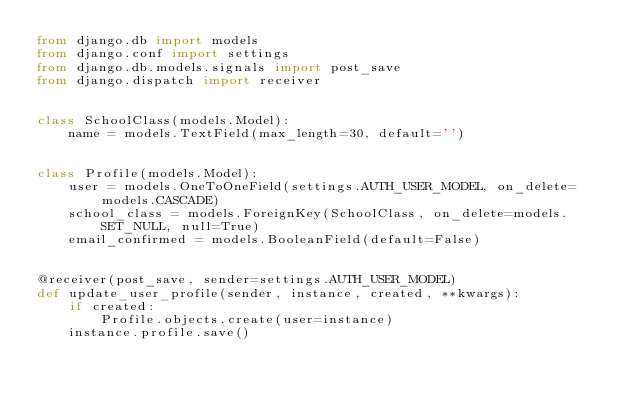<code> <loc_0><loc_0><loc_500><loc_500><_Python_>from django.db import models
from django.conf import settings
from django.db.models.signals import post_save
from django.dispatch import receiver


class SchoolClass(models.Model):
    name = models.TextField(max_length=30, default='')


class Profile(models.Model):
    user = models.OneToOneField(settings.AUTH_USER_MODEL, on_delete=models.CASCADE)
    school_class = models.ForeignKey(SchoolClass, on_delete=models.SET_NULL, null=True)
    email_confirmed = models.BooleanField(default=False)


@receiver(post_save, sender=settings.AUTH_USER_MODEL)
def update_user_profile(sender, instance, created, **kwargs):
    if created:
        Profile.objects.create(user=instance)
    instance.profile.save()
</code> 